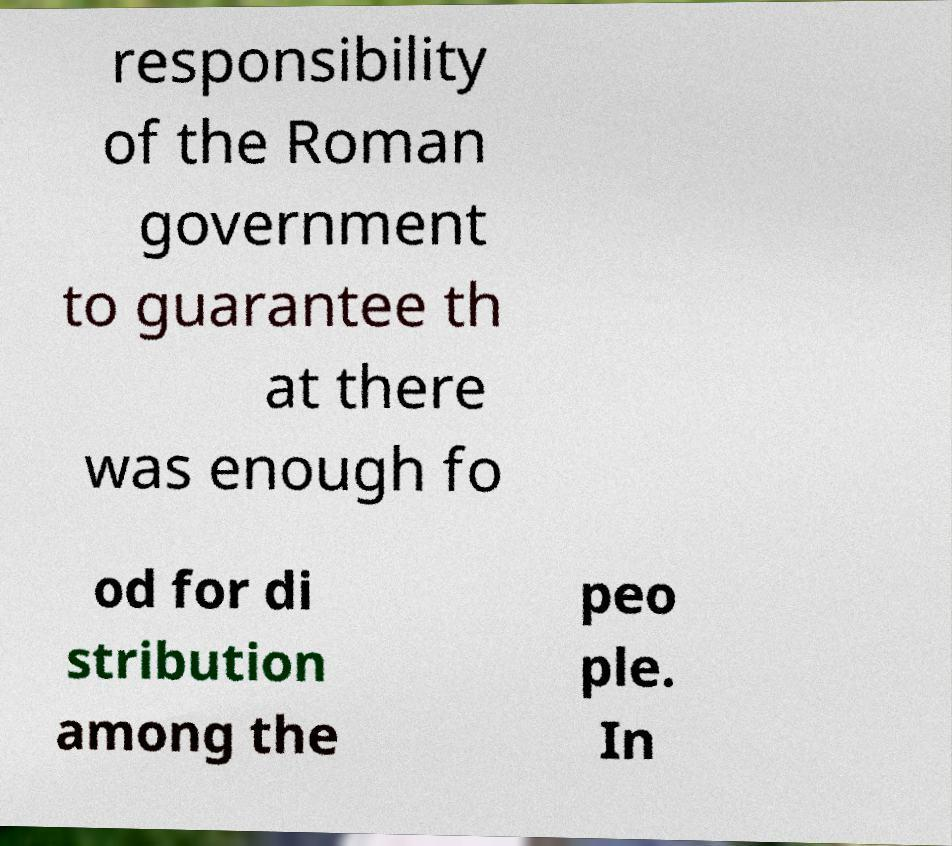There's text embedded in this image that I need extracted. Can you transcribe it verbatim? responsibility of the Roman government to guarantee th at there was enough fo od for di stribution among the peo ple. In 